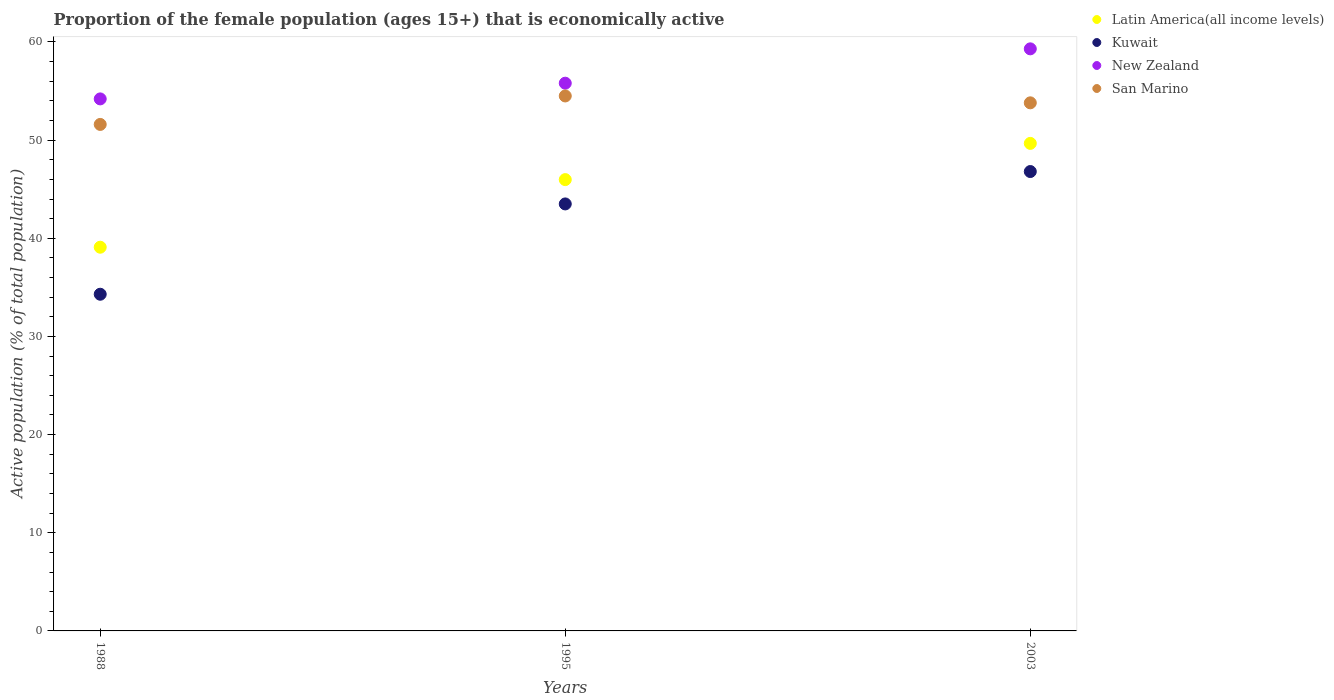What is the proportion of the female population that is economically active in Latin America(all income levels) in 2003?
Provide a short and direct response. 49.67. Across all years, what is the maximum proportion of the female population that is economically active in San Marino?
Make the answer very short. 54.5. Across all years, what is the minimum proportion of the female population that is economically active in Kuwait?
Offer a terse response. 34.3. In which year was the proportion of the female population that is economically active in New Zealand maximum?
Offer a very short reply. 2003. In which year was the proportion of the female population that is economically active in New Zealand minimum?
Provide a succinct answer. 1988. What is the total proportion of the female population that is economically active in Latin America(all income levels) in the graph?
Provide a succinct answer. 134.74. What is the difference between the proportion of the female population that is economically active in Kuwait in 1988 and that in 1995?
Make the answer very short. -9.2. What is the average proportion of the female population that is economically active in New Zealand per year?
Make the answer very short. 56.43. In the year 2003, what is the difference between the proportion of the female population that is economically active in Kuwait and proportion of the female population that is economically active in San Marino?
Provide a short and direct response. -7. In how many years, is the proportion of the female population that is economically active in San Marino greater than 34 %?
Provide a short and direct response. 3. What is the ratio of the proportion of the female population that is economically active in Kuwait in 1988 to that in 1995?
Offer a terse response. 0.79. Is the difference between the proportion of the female population that is economically active in Kuwait in 1988 and 2003 greater than the difference between the proportion of the female population that is economically active in San Marino in 1988 and 2003?
Make the answer very short. No. What is the difference between the highest and the second highest proportion of the female population that is economically active in New Zealand?
Provide a short and direct response. 3.5. What is the difference between the highest and the lowest proportion of the female population that is economically active in New Zealand?
Keep it short and to the point. 5.1. Is the sum of the proportion of the female population that is economically active in Kuwait in 1988 and 1995 greater than the maximum proportion of the female population that is economically active in New Zealand across all years?
Your answer should be compact. Yes. Is it the case that in every year, the sum of the proportion of the female population that is economically active in San Marino and proportion of the female population that is economically active in New Zealand  is greater than the sum of proportion of the female population that is economically active in Kuwait and proportion of the female population that is economically active in Latin America(all income levels)?
Give a very brief answer. Yes. Is it the case that in every year, the sum of the proportion of the female population that is economically active in Kuwait and proportion of the female population that is economically active in San Marino  is greater than the proportion of the female population that is economically active in Latin America(all income levels)?
Provide a short and direct response. Yes. Does the proportion of the female population that is economically active in Kuwait monotonically increase over the years?
Ensure brevity in your answer.  Yes. Is the proportion of the female population that is economically active in San Marino strictly less than the proportion of the female population that is economically active in Kuwait over the years?
Ensure brevity in your answer.  No. How many dotlines are there?
Your answer should be very brief. 4. How many years are there in the graph?
Provide a short and direct response. 3. What is the difference between two consecutive major ticks on the Y-axis?
Give a very brief answer. 10. How are the legend labels stacked?
Make the answer very short. Vertical. What is the title of the graph?
Make the answer very short. Proportion of the female population (ages 15+) that is economically active. What is the label or title of the Y-axis?
Keep it short and to the point. Active population (% of total population). What is the Active population (% of total population) of Latin America(all income levels) in 1988?
Your answer should be very brief. 39.09. What is the Active population (% of total population) in Kuwait in 1988?
Your answer should be compact. 34.3. What is the Active population (% of total population) of New Zealand in 1988?
Your answer should be compact. 54.2. What is the Active population (% of total population) of San Marino in 1988?
Your answer should be compact. 51.6. What is the Active population (% of total population) in Latin America(all income levels) in 1995?
Your answer should be very brief. 45.98. What is the Active population (% of total population) of Kuwait in 1995?
Give a very brief answer. 43.5. What is the Active population (% of total population) of New Zealand in 1995?
Offer a very short reply. 55.8. What is the Active population (% of total population) in San Marino in 1995?
Ensure brevity in your answer.  54.5. What is the Active population (% of total population) of Latin America(all income levels) in 2003?
Your response must be concise. 49.67. What is the Active population (% of total population) of Kuwait in 2003?
Your answer should be compact. 46.8. What is the Active population (% of total population) of New Zealand in 2003?
Offer a very short reply. 59.3. What is the Active population (% of total population) in San Marino in 2003?
Keep it short and to the point. 53.8. Across all years, what is the maximum Active population (% of total population) in Latin America(all income levels)?
Provide a short and direct response. 49.67. Across all years, what is the maximum Active population (% of total population) in Kuwait?
Your answer should be compact. 46.8. Across all years, what is the maximum Active population (% of total population) of New Zealand?
Offer a very short reply. 59.3. Across all years, what is the maximum Active population (% of total population) in San Marino?
Your answer should be compact. 54.5. Across all years, what is the minimum Active population (% of total population) in Latin America(all income levels)?
Provide a short and direct response. 39.09. Across all years, what is the minimum Active population (% of total population) in Kuwait?
Make the answer very short. 34.3. Across all years, what is the minimum Active population (% of total population) of New Zealand?
Keep it short and to the point. 54.2. Across all years, what is the minimum Active population (% of total population) of San Marino?
Provide a succinct answer. 51.6. What is the total Active population (% of total population) in Latin America(all income levels) in the graph?
Offer a very short reply. 134.74. What is the total Active population (% of total population) of Kuwait in the graph?
Give a very brief answer. 124.6. What is the total Active population (% of total population) in New Zealand in the graph?
Make the answer very short. 169.3. What is the total Active population (% of total population) in San Marino in the graph?
Ensure brevity in your answer.  159.9. What is the difference between the Active population (% of total population) of Latin America(all income levels) in 1988 and that in 1995?
Ensure brevity in your answer.  -6.89. What is the difference between the Active population (% of total population) of San Marino in 1988 and that in 1995?
Make the answer very short. -2.9. What is the difference between the Active population (% of total population) in Latin America(all income levels) in 1988 and that in 2003?
Ensure brevity in your answer.  -10.58. What is the difference between the Active population (% of total population) in New Zealand in 1988 and that in 2003?
Your response must be concise. -5.1. What is the difference between the Active population (% of total population) of San Marino in 1988 and that in 2003?
Your answer should be compact. -2.2. What is the difference between the Active population (% of total population) in Latin America(all income levels) in 1995 and that in 2003?
Your response must be concise. -3.69. What is the difference between the Active population (% of total population) of Kuwait in 1995 and that in 2003?
Provide a succinct answer. -3.3. What is the difference between the Active population (% of total population) in New Zealand in 1995 and that in 2003?
Give a very brief answer. -3.5. What is the difference between the Active population (% of total population) in Latin America(all income levels) in 1988 and the Active population (% of total population) in Kuwait in 1995?
Offer a terse response. -4.41. What is the difference between the Active population (% of total population) in Latin America(all income levels) in 1988 and the Active population (% of total population) in New Zealand in 1995?
Give a very brief answer. -16.71. What is the difference between the Active population (% of total population) in Latin America(all income levels) in 1988 and the Active population (% of total population) in San Marino in 1995?
Keep it short and to the point. -15.41. What is the difference between the Active population (% of total population) in Kuwait in 1988 and the Active population (% of total population) in New Zealand in 1995?
Your answer should be very brief. -21.5. What is the difference between the Active population (% of total population) in Kuwait in 1988 and the Active population (% of total population) in San Marino in 1995?
Your answer should be compact. -20.2. What is the difference between the Active population (% of total population) of Latin America(all income levels) in 1988 and the Active population (% of total population) of Kuwait in 2003?
Offer a very short reply. -7.71. What is the difference between the Active population (% of total population) of Latin America(all income levels) in 1988 and the Active population (% of total population) of New Zealand in 2003?
Make the answer very short. -20.21. What is the difference between the Active population (% of total population) of Latin America(all income levels) in 1988 and the Active population (% of total population) of San Marino in 2003?
Offer a terse response. -14.71. What is the difference between the Active population (% of total population) in Kuwait in 1988 and the Active population (% of total population) in New Zealand in 2003?
Your response must be concise. -25. What is the difference between the Active population (% of total population) in Kuwait in 1988 and the Active population (% of total population) in San Marino in 2003?
Ensure brevity in your answer.  -19.5. What is the difference between the Active population (% of total population) in Latin America(all income levels) in 1995 and the Active population (% of total population) in Kuwait in 2003?
Ensure brevity in your answer.  -0.82. What is the difference between the Active population (% of total population) of Latin America(all income levels) in 1995 and the Active population (% of total population) of New Zealand in 2003?
Give a very brief answer. -13.32. What is the difference between the Active population (% of total population) in Latin America(all income levels) in 1995 and the Active population (% of total population) in San Marino in 2003?
Keep it short and to the point. -7.82. What is the difference between the Active population (% of total population) of Kuwait in 1995 and the Active population (% of total population) of New Zealand in 2003?
Your answer should be very brief. -15.8. What is the difference between the Active population (% of total population) in Kuwait in 1995 and the Active population (% of total population) in San Marino in 2003?
Keep it short and to the point. -10.3. What is the average Active population (% of total population) in Latin America(all income levels) per year?
Your answer should be very brief. 44.91. What is the average Active population (% of total population) in Kuwait per year?
Ensure brevity in your answer.  41.53. What is the average Active population (% of total population) in New Zealand per year?
Your answer should be very brief. 56.43. What is the average Active population (% of total population) in San Marino per year?
Your answer should be compact. 53.3. In the year 1988, what is the difference between the Active population (% of total population) in Latin America(all income levels) and Active population (% of total population) in Kuwait?
Give a very brief answer. 4.79. In the year 1988, what is the difference between the Active population (% of total population) of Latin America(all income levels) and Active population (% of total population) of New Zealand?
Provide a succinct answer. -15.11. In the year 1988, what is the difference between the Active population (% of total population) of Latin America(all income levels) and Active population (% of total population) of San Marino?
Offer a very short reply. -12.51. In the year 1988, what is the difference between the Active population (% of total population) in Kuwait and Active population (% of total population) in New Zealand?
Give a very brief answer. -19.9. In the year 1988, what is the difference between the Active population (% of total population) in Kuwait and Active population (% of total population) in San Marino?
Keep it short and to the point. -17.3. In the year 1988, what is the difference between the Active population (% of total population) of New Zealand and Active population (% of total population) of San Marino?
Ensure brevity in your answer.  2.6. In the year 1995, what is the difference between the Active population (% of total population) of Latin America(all income levels) and Active population (% of total population) of Kuwait?
Provide a succinct answer. 2.48. In the year 1995, what is the difference between the Active population (% of total population) of Latin America(all income levels) and Active population (% of total population) of New Zealand?
Offer a terse response. -9.82. In the year 1995, what is the difference between the Active population (% of total population) in Latin America(all income levels) and Active population (% of total population) in San Marino?
Keep it short and to the point. -8.52. In the year 2003, what is the difference between the Active population (% of total population) of Latin America(all income levels) and Active population (% of total population) of Kuwait?
Offer a terse response. 2.87. In the year 2003, what is the difference between the Active population (% of total population) of Latin America(all income levels) and Active population (% of total population) of New Zealand?
Offer a terse response. -9.63. In the year 2003, what is the difference between the Active population (% of total population) of Latin America(all income levels) and Active population (% of total population) of San Marino?
Ensure brevity in your answer.  -4.13. What is the ratio of the Active population (% of total population) in Latin America(all income levels) in 1988 to that in 1995?
Provide a short and direct response. 0.85. What is the ratio of the Active population (% of total population) of Kuwait in 1988 to that in 1995?
Keep it short and to the point. 0.79. What is the ratio of the Active population (% of total population) in New Zealand in 1988 to that in 1995?
Provide a succinct answer. 0.97. What is the ratio of the Active population (% of total population) in San Marino in 1988 to that in 1995?
Ensure brevity in your answer.  0.95. What is the ratio of the Active population (% of total population) of Latin America(all income levels) in 1988 to that in 2003?
Make the answer very short. 0.79. What is the ratio of the Active population (% of total population) in Kuwait in 1988 to that in 2003?
Keep it short and to the point. 0.73. What is the ratio of the Active population (% of total population) in New Zealand in 1988 to that in 2003?
Provide a short and direct response. 0.91. What is the ratio of the Active population (% of total population) in San Marino in 1988 to that in 2003?
Provide a succinct answer. 0.96. What is the ratio of the Active population (% of total population) of Latin America(all income levels) in 1995 to that in 2003?
Your response must be concise. 0.93. What is the ratio of the Active population (% of total population) in Kuwait in 1995 to that in 2003?
Give a very brief answer. 0.93. What is the ratio of the Active population (% of total population) of New Zealand in 1995 to that in 2003?
Offer a very short reply. 0.94. What is the ratio of the Active population (% of total population) in San Marino in 1995 to that in 2003?
Give a very brief answer. 1.01. What is the difference between the highest and the second highest Active population (% of total population) in Latin America(all income levels)?
Give a very brief answer. 3.69. What is the difference between the highest and the second highest Active population (% of total population) of San Marino?
Offer a terse response. 0.7. What is the difference between the highest and the lowest Active population (% of total population) of Latin America(all income levels)?
Offer a very short reply. 10.58. What is the difference between the highest and the lowest Active population (% of total population) in Kuwait?
Your response must be concise. 12.5. What is the difference between the highest and the lowest Active population (% of total population) in New Zealand?
Offer a very short reply. 5.1. What is the difference between the highest and the lowest Active population (% of total population) in San Marino?
Give a very brief answer. 2.9. 